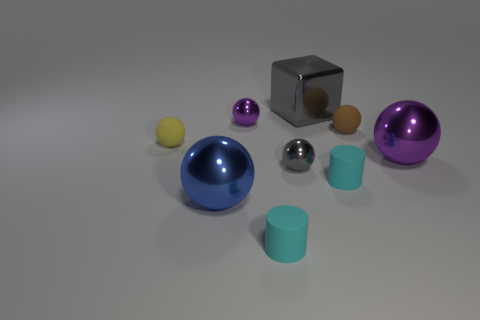There is a cyan matte cylinder in front of the big shiny thing on the left side of the big block; how big is it?
Your answer should be very brief. Small. What is the cylinder left of the large cube made of?
Provide a short and direct response. Rubber. What size is the other ball that is made of the same material as the brown ball?
Your answer should be very brief. Small. What number of small red rubber objects have the same shape as the small gray thing?
Give a very brief answer. 0. Is the shape of the brown thing the same as the gray thing on the left side of the large gray metallic cube?
Your answer should be very brief. Yes. Are there any other things that have the same material as the brown object?
Provide a short and direct response. Yes. What material is the big ball that is on the left side of the gray thing behind the tiny gray shiny thing?
Keep it short and to the point. Metal. There is a matte ball that is on the right side of the small metal thing behind the large purple metal sphere that is behind the blue object; how big is it?
Make the answer very short. Small. What number of other objects are there of the same shape as the large gray object?
Provide a succinct answer. 0. Is the color of the big sphere behind the large blue object the same as the metal ball that is behind the large purple metal thing?
Your answer should be compact. Yes. 